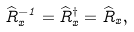<formula> <loc_0><loc_0><loc_500><loc_500>\widehat { R } _ { x } ^ { - 1 } = \widehat { R } _ { x } ^ { \dag } = \widehat { R } _ { x } ,</formula> 